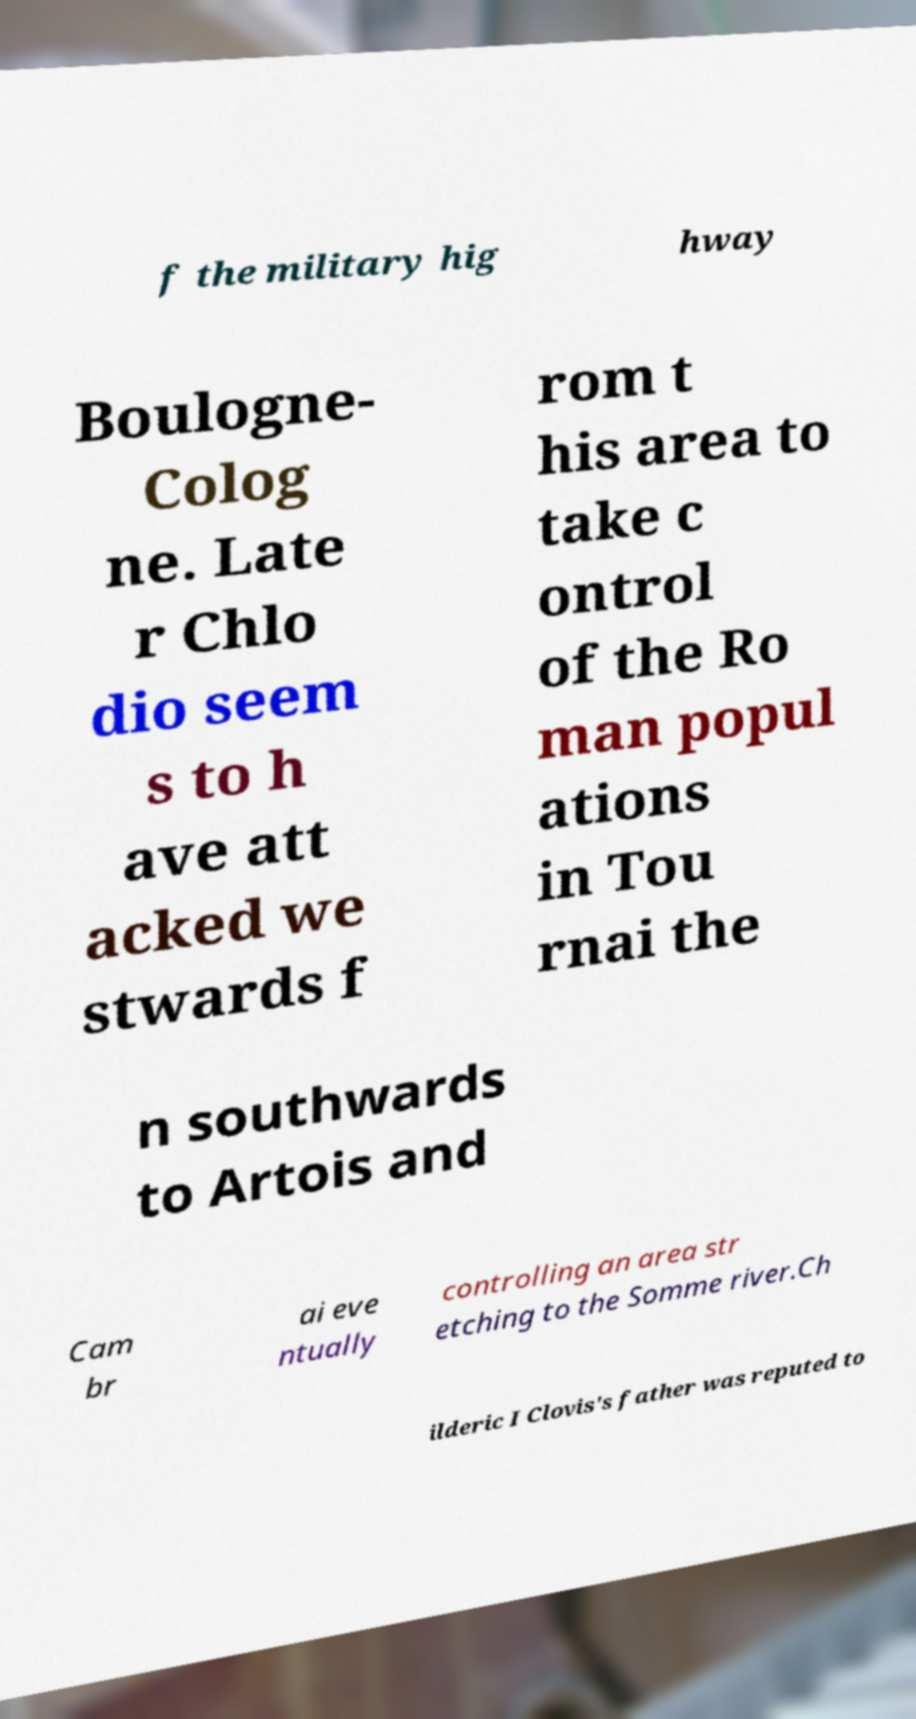For documentation purposes, I need the text within this image transcribed. Could you provide that? f the military hig hway Boulogne- Colog ne. Late r Chlo dio seem s to h ave att acked we stwards f rom t his area to take c ontrol of the Ro man popul ations in Tou rnai the n southwards to Artois and Cam br ai eve ntually controlling an area str etching to the Somme river.Ch ilderic I Clovis's father was reputed to 